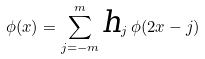Convert formula to latex. <formula><loc_0><loc_0><loc_500><loc_500>\phi ( x ) = \sum _ { j = - m } ^ { m } \text {\sl h} _ { j } \, \phi ( 2 x - j )</formula> 